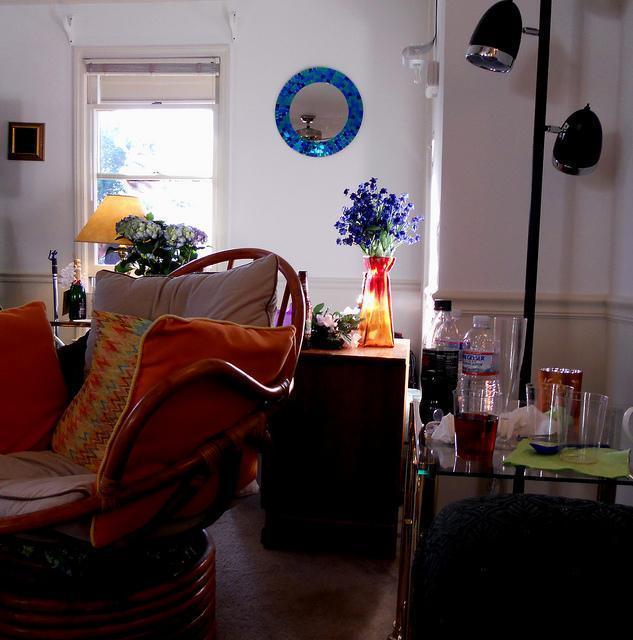How many bottles are in the picture?
Give a very brief answer. 2. How many cups are there?
Give a very brief answer. 3. How many people have blonde hair?
Give a very brief answer. 0. 